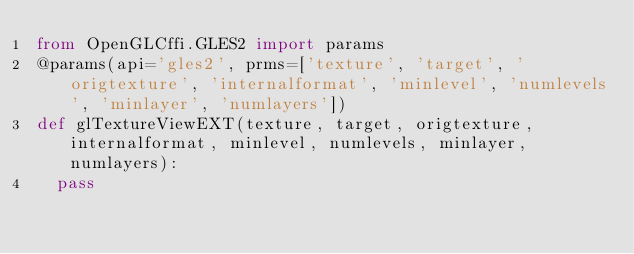Convert code to text. <code><loc_0><loc_0><loc_500><loc_500><_Python_>from OpenGLCffi.GLES2 import params
@params(api='gles2', prms=['texture', 'target', 'origtexture', 'internalformat', 'minlevel', 'numlevels', 'minlayer', 'numlayers'])
def glTextureViewEXT(texture, target, origtexture, internalformat, minlevel, numlevels, minlayer, numlayers):
	pass


</code> 